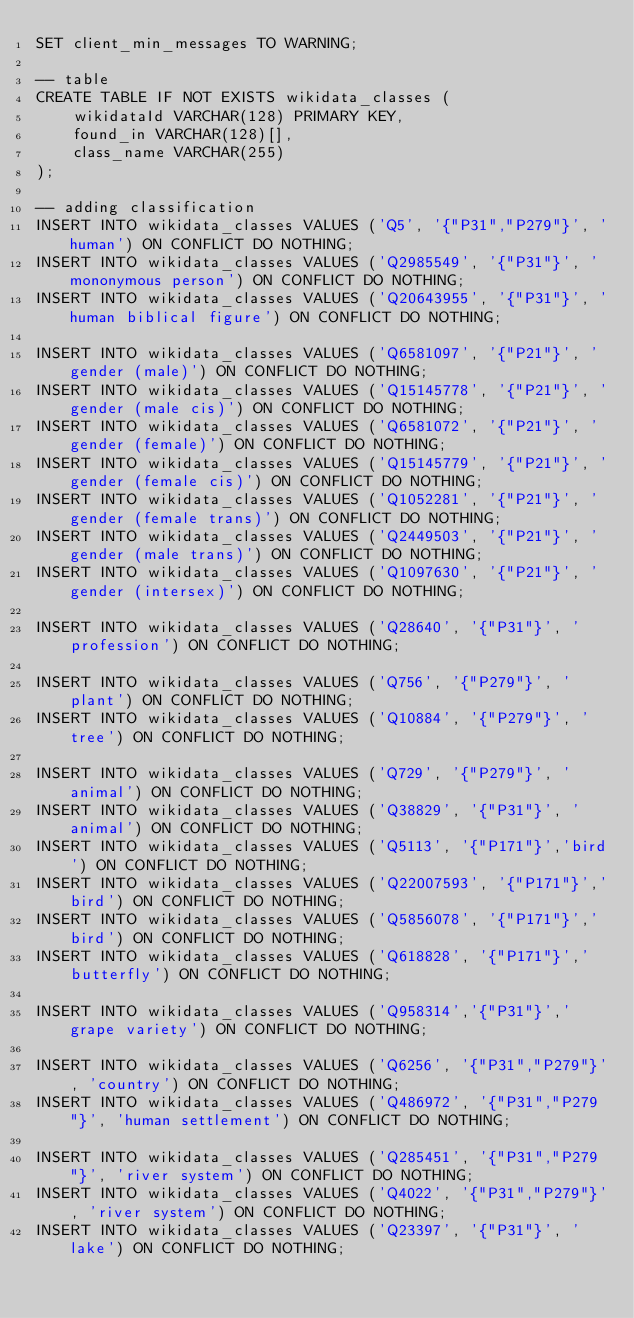<code> <loc_0><loc_0><loc_500><loc_500><_SQL_>SET client_min_messages TO WARNING;

-- table
CREATE TABLE IF NOT EXISTS wikidata_classes (
    wikidataId VARCHAR(128) PRIMARY KEY,
    found_in VARCHAR(128)[],
    class_name VARCHAR(255)
);

-- adding classification
INSERT INTO wikidata_classes VALUES ('Q5', '{"P31","P279"}', 'human') ON CONFLICT DO NOTHING;
INSERT INTO wikidata_classes VALUES ('Q2985549', '{"P31"}', 'mononymous person') ON CONFLICT DO NOTHING;
INSERT INTO wikidata_classes VALUES ('Q20643955', '{"P31"}', 'human biblical figure') ON CONFLICT DO NOTHING;

INSERT INTO wikidata_classes VALUES ('Q6581097', '{"P21"}', 'gender (male)') ON CONFLICT DO NOTHING;
INSERT INTO wikidata_classes VALUES ('Q15145778', '{"P21"}', 'gender (male cis)') ON CONFLICT DO NOTHING;
INSERT INTO wikidata_classes VALUES ('Q6581072', '{"P21"}', 'gender (female)') ON CONFLICT DO NOTHING;
INSERT INTO wikidata_classes VALUES ('Q15145779', '{"P21"}', 'gender (female cis)') ON CONFLICT DO NOTHING;
INSERT INTO wikidata_classes VALUES ('Q1052281', '{"P21"}', 'gender (female trans)') ON CONFLICT DO NOTHING;
INSERT INTO wikidata_classes VALUES ('Q2449503', '{"P21"}', 'gender (male trans)') ON CONFLICT DO NOTHING;
INSERT INTO wikidata_classes VALUES ('Q1097630', '{"P21"}', 'gender (intersex)') ON CONFLICT DO NOTHING;

INSERT INTO wikidata_classes VALUES ('Q28640', '{"P31"}', 'profession') ON CONFLICT DO NOTHING;

INSERT INTO wikidata_classes VALUES ('Q756', '{"P279"}', 'plant') ON CONFLICT DO NOTHING;
INSERT INTO wikidata_classes VALUES ('Q10884', '{"P279"}', 'tree') ON CONFLICT DO NOTHING;

INSERT INTO wikidata_classes VALUES ('Q729', '{"P279"}', 'animal') ON CONFLICT DO NOTHING;
INSERT INTO wikidata_classes VALUES ('Q38829', '{"P31"}', 'animal') ON CONFLICT DO NOTHING;
INSERT INTO wikidata_classes VALUES ('Q5113', '{"P171"}','bird') ON CONFLICT DO NOTHING;
INSERT INTO wikidata_classes VALUES ('Q22007593', '{"P171"}','bird') ON CONFLICT DO NOTHING;
INSERT INTO wikidata_classes VALUES ('Q5856078', '{"P171"}','bird') ON CONFLICT DO NOTHING;
INSERT INTO wikidata_classes VALUES ('Q618828', '{"P171"}','butterfly') ON CONFLICT DO NOTHING;

INSERT INTO wikidata_classes VALUES ('Q958314','{"P31"}','grape variety') ON CONFLICT DO NOTHING;

INSERT INTO wikidata_classes VALUES ('Q6256', '{"P31","P279"}', 'country') ON CONFLICT DO NOTHING;
INSERT INTO wikidata_classes VALUES ('Q486972', '{"P31","P279"}', 'human settlement') ON CONFLICT DO NOTHING;

INSERT INTO wikidata_classes VALUES ('Q285451', '{"P31","P279"}', 'river system') ON CONFLICT DO NOTHING;
INSERT INTO wikidata_classes VALUES ('Q4022', '{"P31","P279"}', 'river system') ON CONFLICT DO NOTHING;
INSERT INTO wikidata_classes VALUES ('Q23397', '{"P31"}', 'lake') ON CONFLICT DO NOTHING;
</code> 